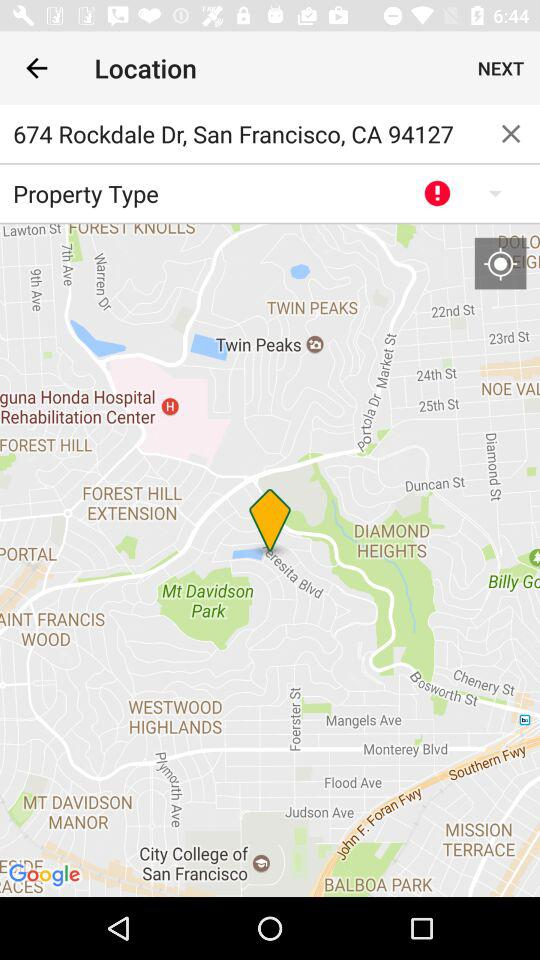What is the location? The location is 674 Rockdale Drive, San Francisco, CA 94127. 